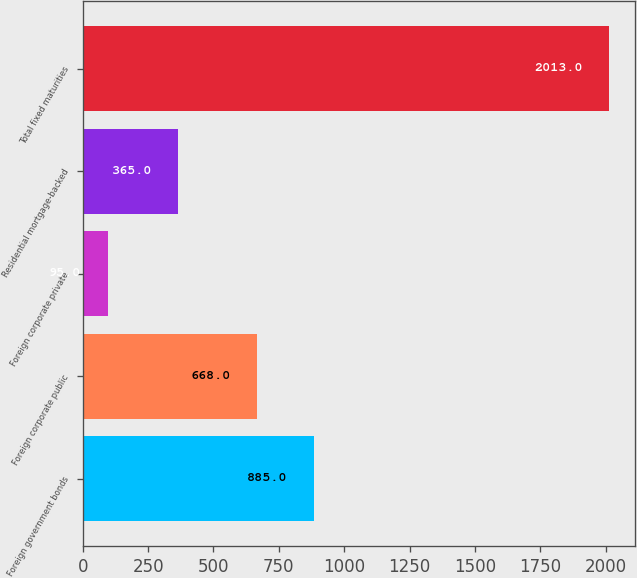Convert chart. <chart><loc_0><loc_0><loc_500><loc_500><bar_chart><fcel>Foreign government bonds<fcel>Foreign corporate public<fcel>Foreign corporate private<fcel>Residential mortgage-backed<fcel>Total fixed maturities<nl><fcel>885<fcel>668<fcel>95<fcel>365<fcel>2013<nl></chart> 